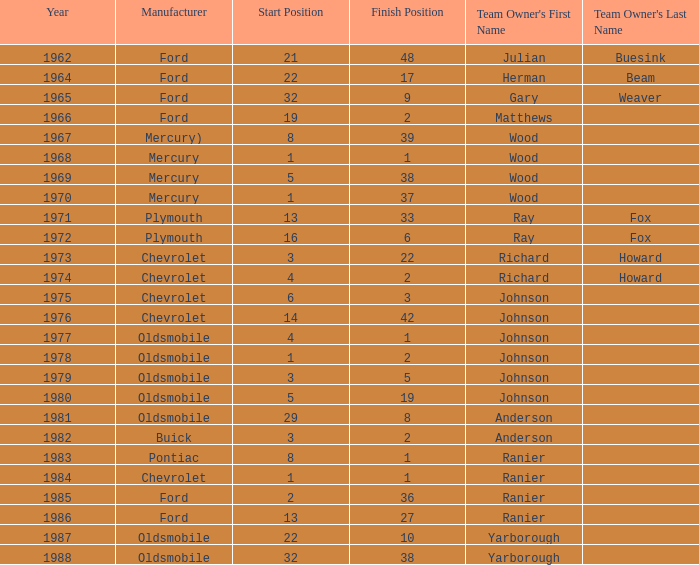What is the smallest finish time for a race after 1972 with a car manufactured by pontiac? 1.0. 